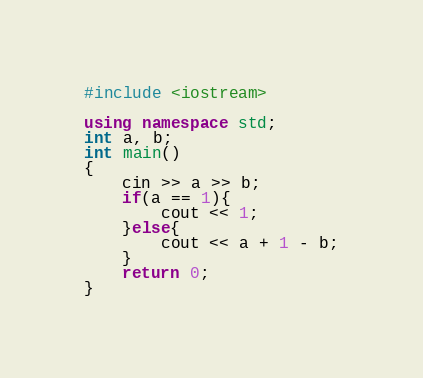Convert code to text. <code><loc_0><loc_0><loc_500><loc_500><_C++_>#include <iostream>

using namespace std;
int a, b;
int main()
{
    cin >> a >> b;
    if(a == 1){
        cout << 1;
    }else{
        cout << a + 1 - b;
    }
    return 0;
}
</code> 